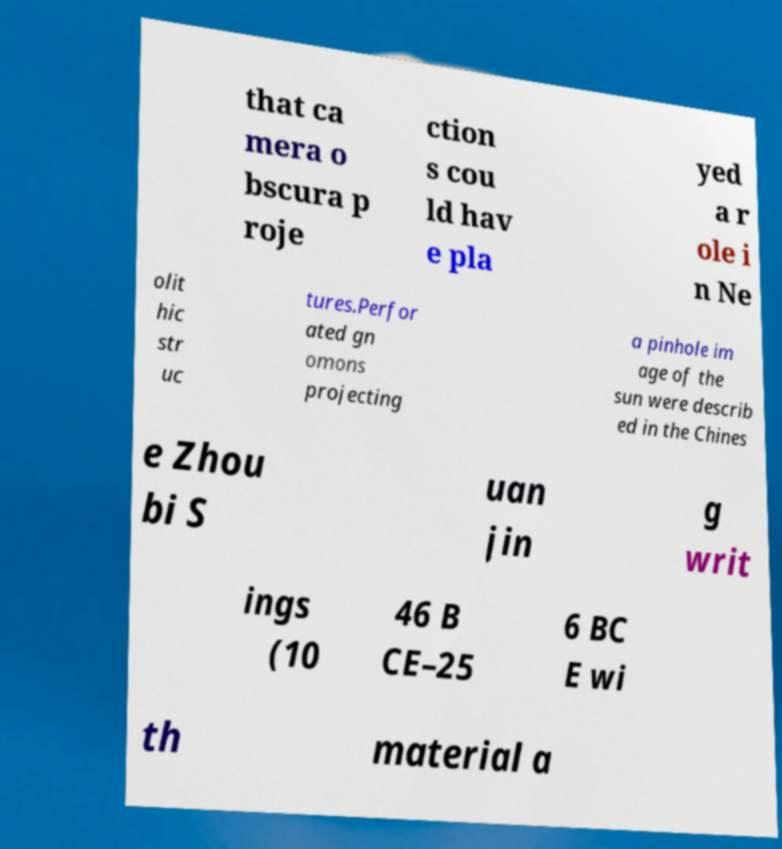For documentation purposes, I need the text within this image transcribed. Could you provide that? that ca mera o bscura p roje ction s cou ld hav e pla yed a r ole i n Ne olit hic str uc tures.Perfor ated gn omons projecting a pinhole im age of the sun were describ ed in the Chines e Zhou bi S uan jin g writ ings (10 46 B CE–25 6 BC E wi th material a 